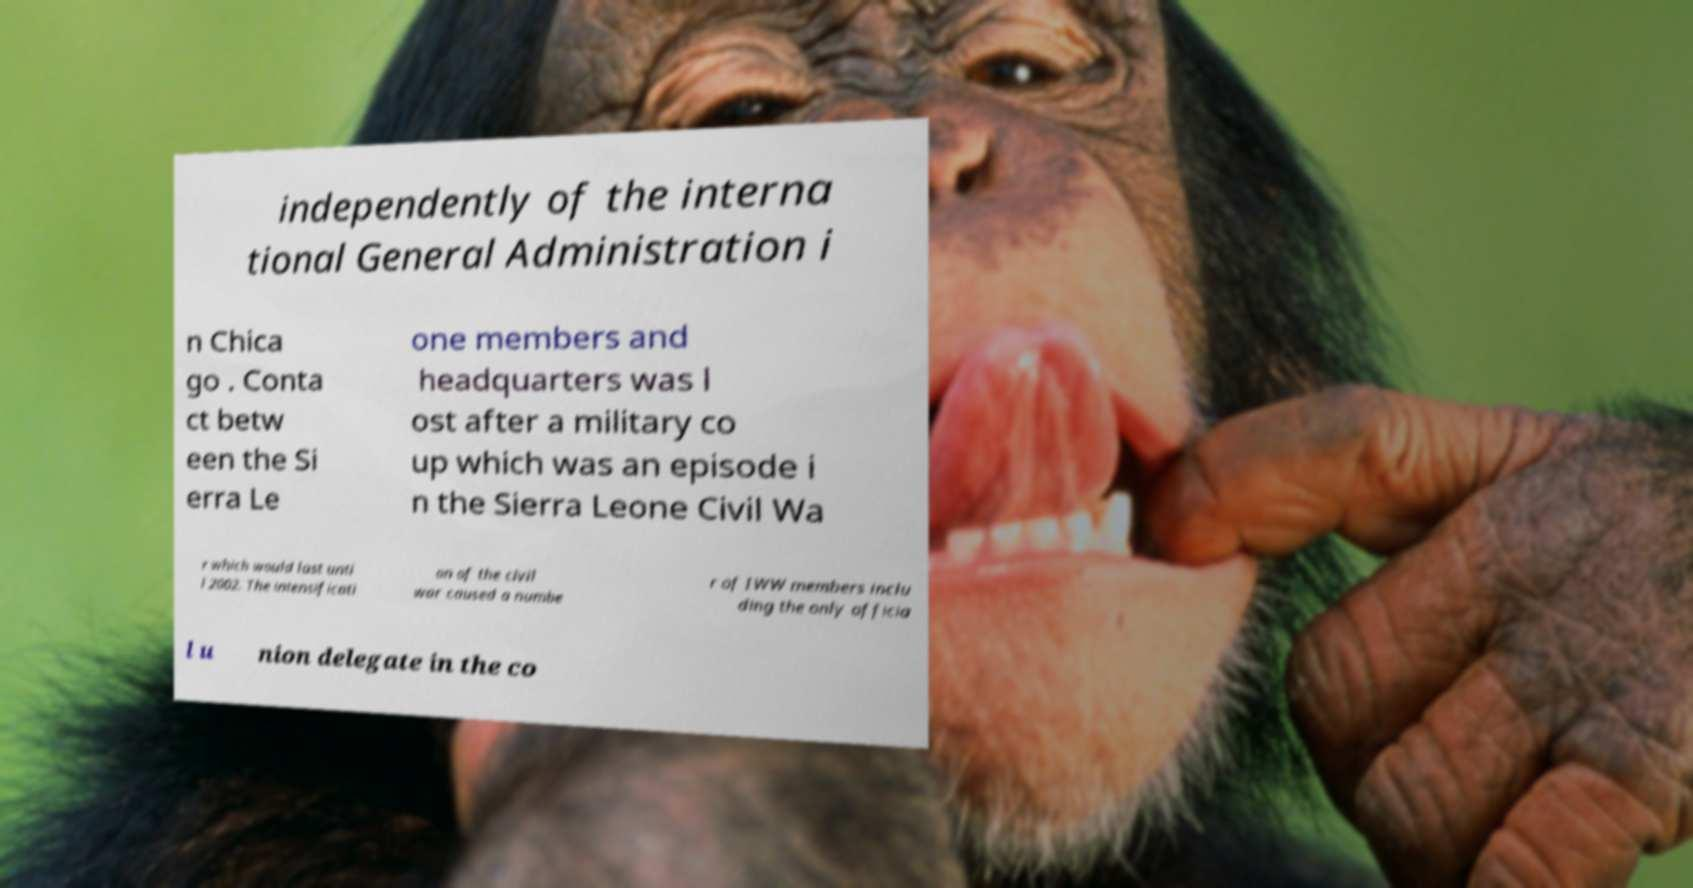Please identify and transcribe the text found in this image. independently of the interna tional General Administration i n Chica go . Conta ct betw een the Si erra Le one members and headquarters was l ost after a military co up which was an episode i n the Sierra Leone Civil Wa r which would last unti l 2002. The intensificati on of the civil war caused a numbe r of IWW members inclu ding the only officia l u nion delegate in the co 